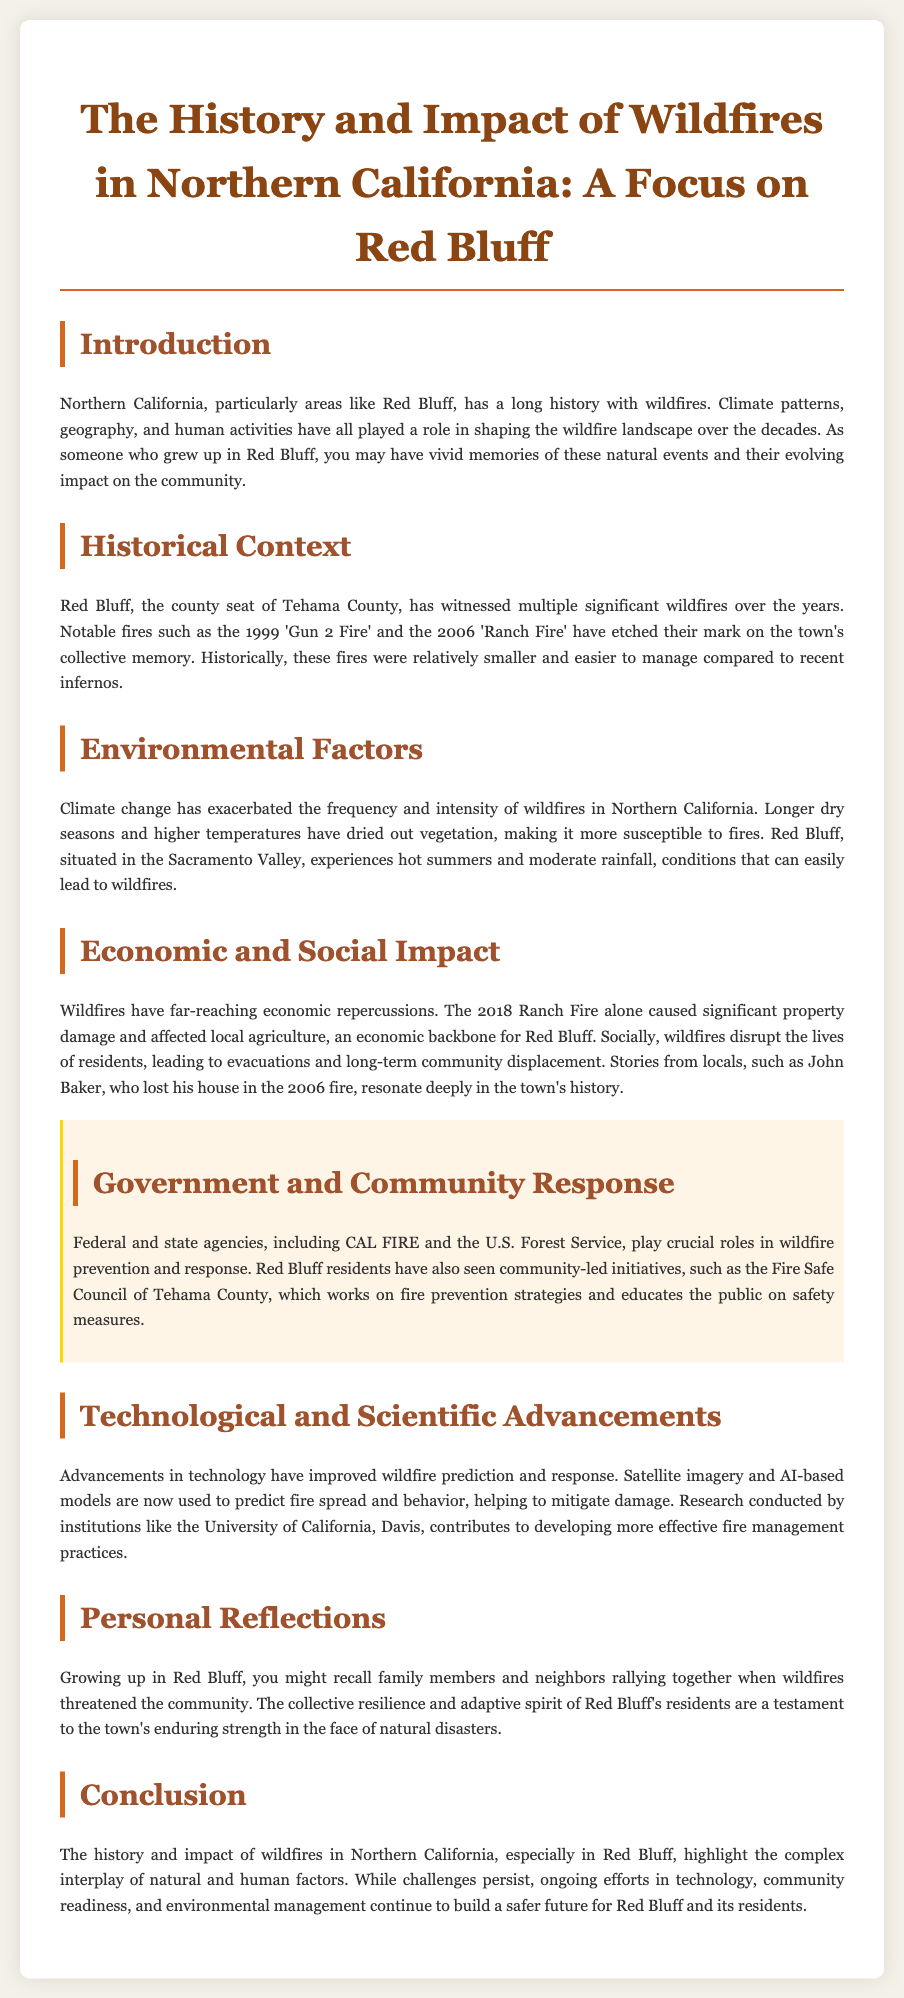What significant wildfires are mentioned in the document? The document names notable fires such as the 'Gun 2 Fire' and the 'Ranch Fire', highlighting their significance in Red Bluff's history.
Answer: 'Gun 2 Fire', 'Ranch Fire' What year did the 'Ranch Fire' occur? The document specifies that the 'Ranch Fire' occurred in 2006, placing it within the timeline of significant wildfires in Red Bluff.
Answer: 2006 Which organization plays a crucial role in wildfire response mentioned in the document? The document includes CAL FIRE as a key agency involved in wildfire prevention and response efforts.
Answer: CAL FIRE How has climate change influenced wildfires according to the document? The document indicates that climate change has increased the frequency and intensity of wildfires due to longer dry seasons and higher temperatures.
Answer: Increased frequency and intensity What is a significant economic consequence of the 2018 Ranch Fire? The document mentions significant property damage and impacts on local agriculture, both vital to Red Bluff's economy.
Answer: Property damage and agriculture impact Which local initiative focuses on fire prevention strategies? The document cites the Fire Safe Council of Tehama County as a community-led initiative working on fire prevention and education.
Answer: Fire Safe Council of Tehama County How do advancements in technology contribute to wildfire management? The document explains that satellite imagery and AI-based models help predict fire spread and behavior, improving response efforts.
Answer: Prediction of fire spread and behavior What personal reflection is highlighted about the community's resilience? The document reflects on the collective resilience and adaptive spirit of Red Bluff’s residents when faced with wildfires.
Answer: Collective resilience and adaptive spirit 